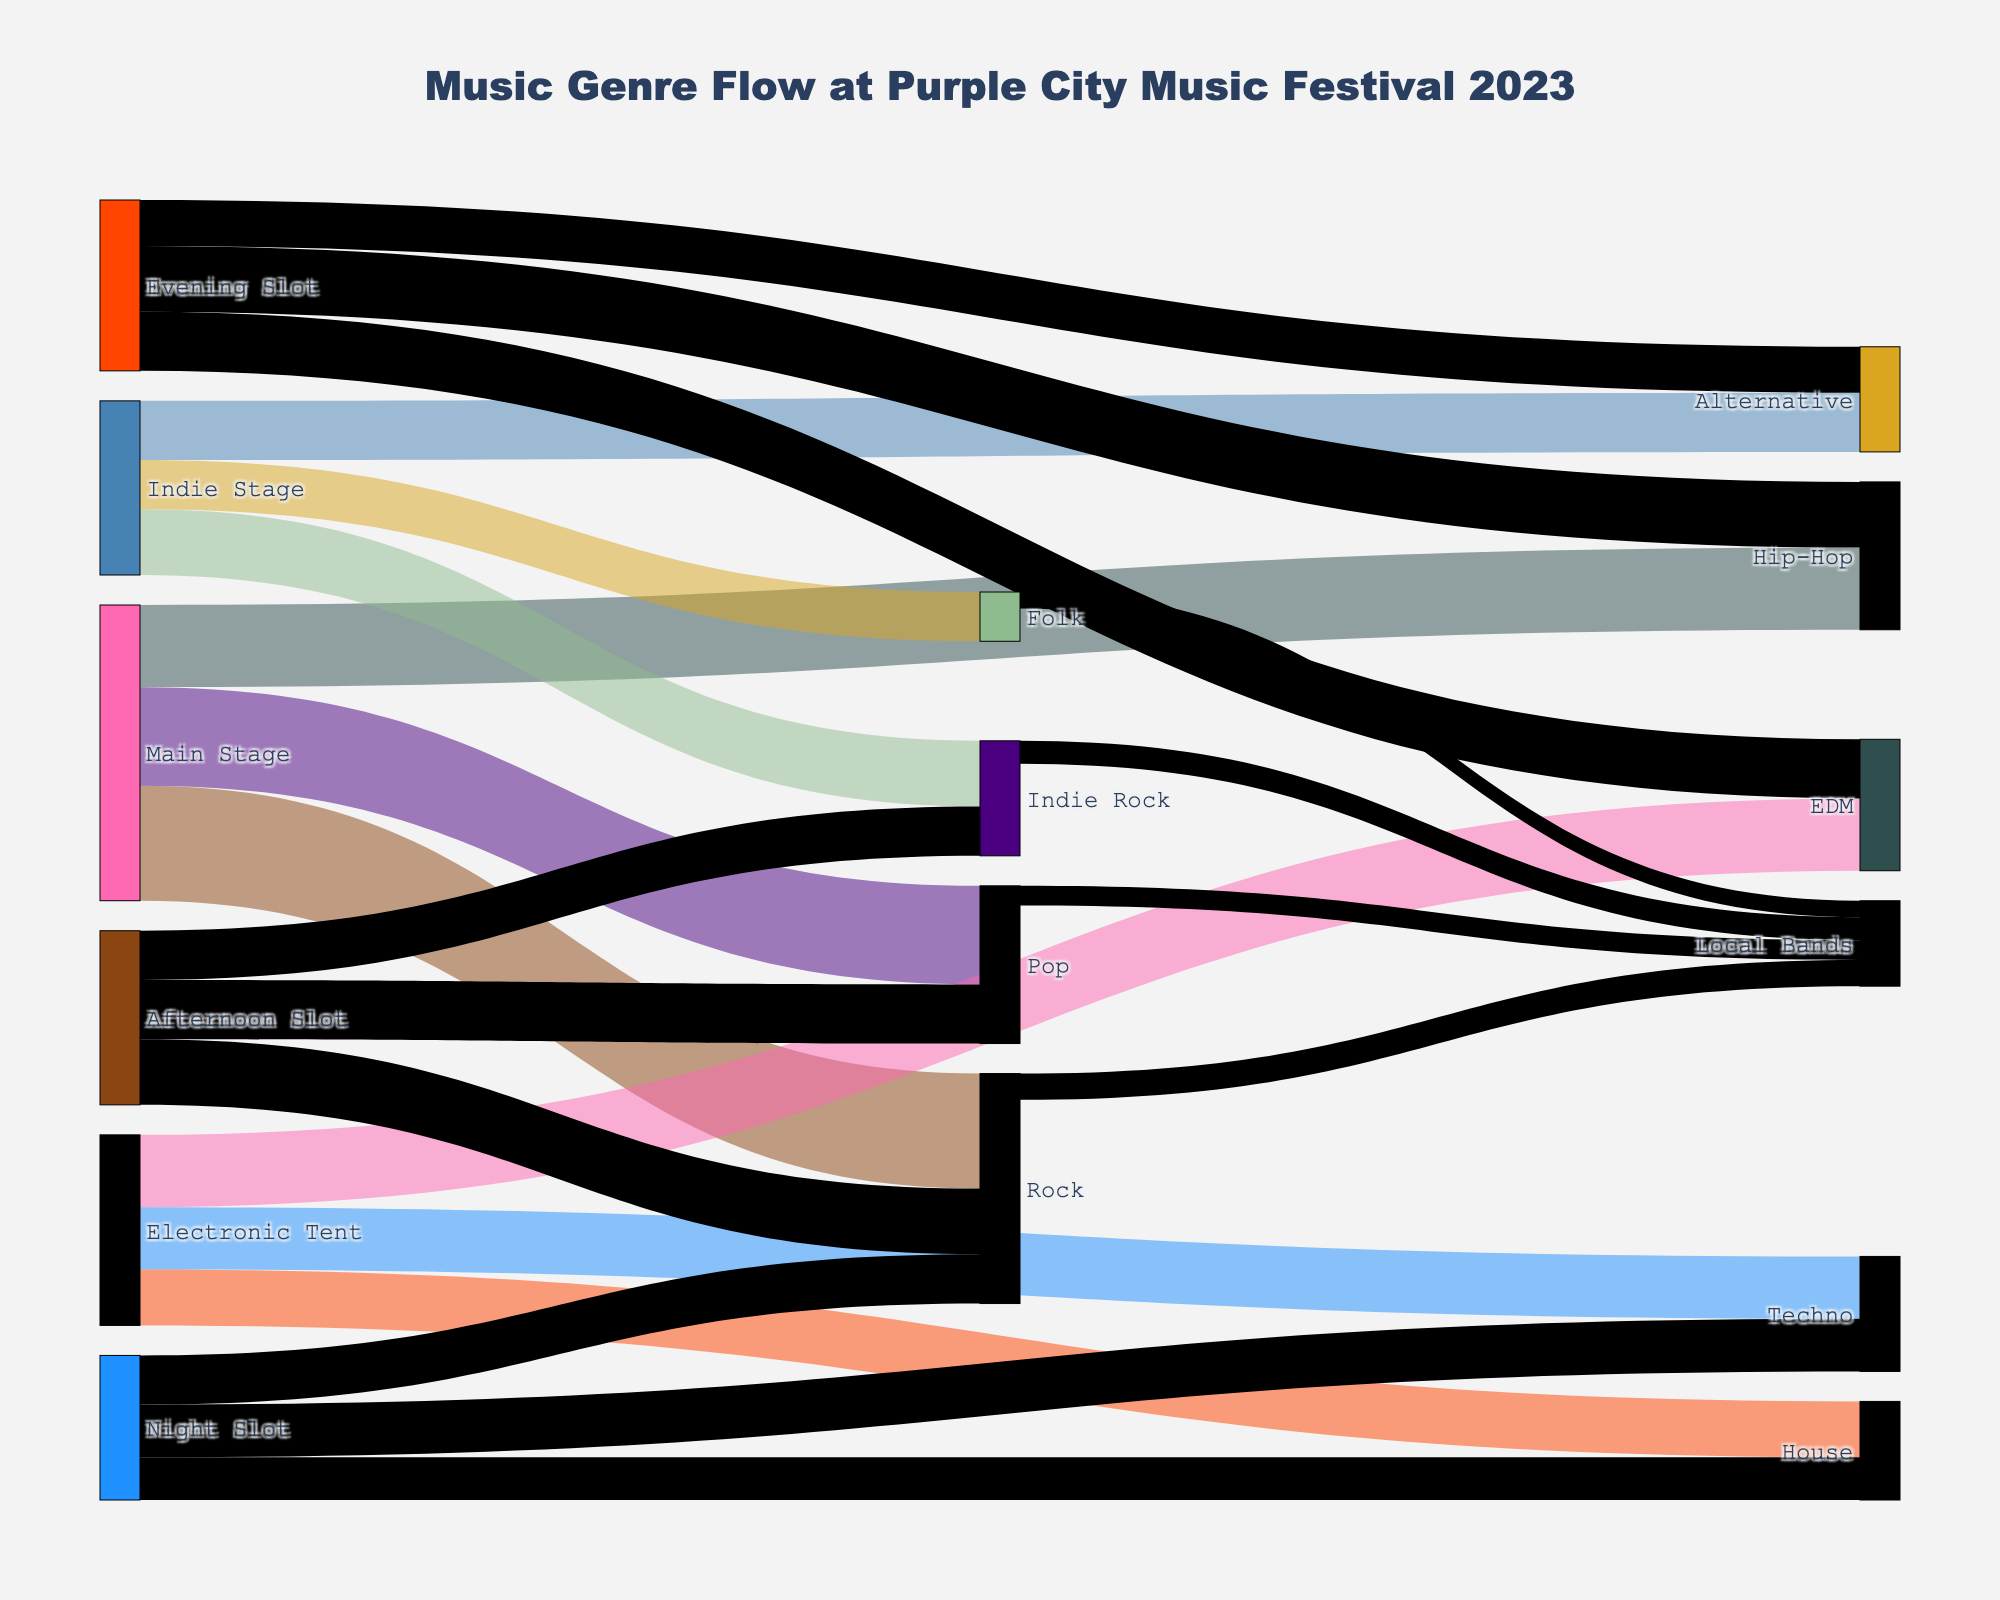How many people attended the Main Stage for Rock music? Look for the flow from "Main Stage" to "Rock" and read the value associated, which is the number of attendees.
Answer: 3500 What music genre had the highest attendance at the Indie Stage? Compare the attendance values for Indie Rock, Folk, and Alternative, identify the highest value.
Answer: Indie Rock Which time slot attracted more people for Pop music, Afternoon or Night? Check the flows labeled "Afternoon Slot" to "Pop" and "Night Slot" to "Pop", and compare their values.
Answer: Afternoon How many total people attended all the stages at the Electronic Tent? Sum up the attendees for EDM, Techno, and House under the "Electronic Tent". 2200 + 1900 + 1700 = 5800
Answer: 5800 What is the total attendance for the Evening Slot across all genres? Sum up the attendance figures for the Evening Slot, including Hip-Hop, EDM, and Alternative. 2000 + 1800 + 1400 = 5200
Answer: 5200 Which genre had the highest number of local bands performing? Compare the values associated with genres: Rock, Pop, Indie Rock, and Folk for local band performances to find the highest.
Answer: Rock How many people attended Techno music at night? Find the flow from "Night Slot" to "Techno" and read the value.
Answer: 1600 Which genre supported by local bands had the lowest performance attendance? Check the flows from local bands to each genre and find the minimum value.
Answer: Folk What is the difference in attendance between Rock and Pop genres on the Main Stage? Subtract the attendance for Pop from the attendance for Rock on the Main Stage. 3500 - 3000 = 500
Answer: 500 Which genre had more afternoon attendees: Rock or Indie Rock? Compare the attendance values for afternoon slots of Rock and Indie Rock.
Answer: Rock 